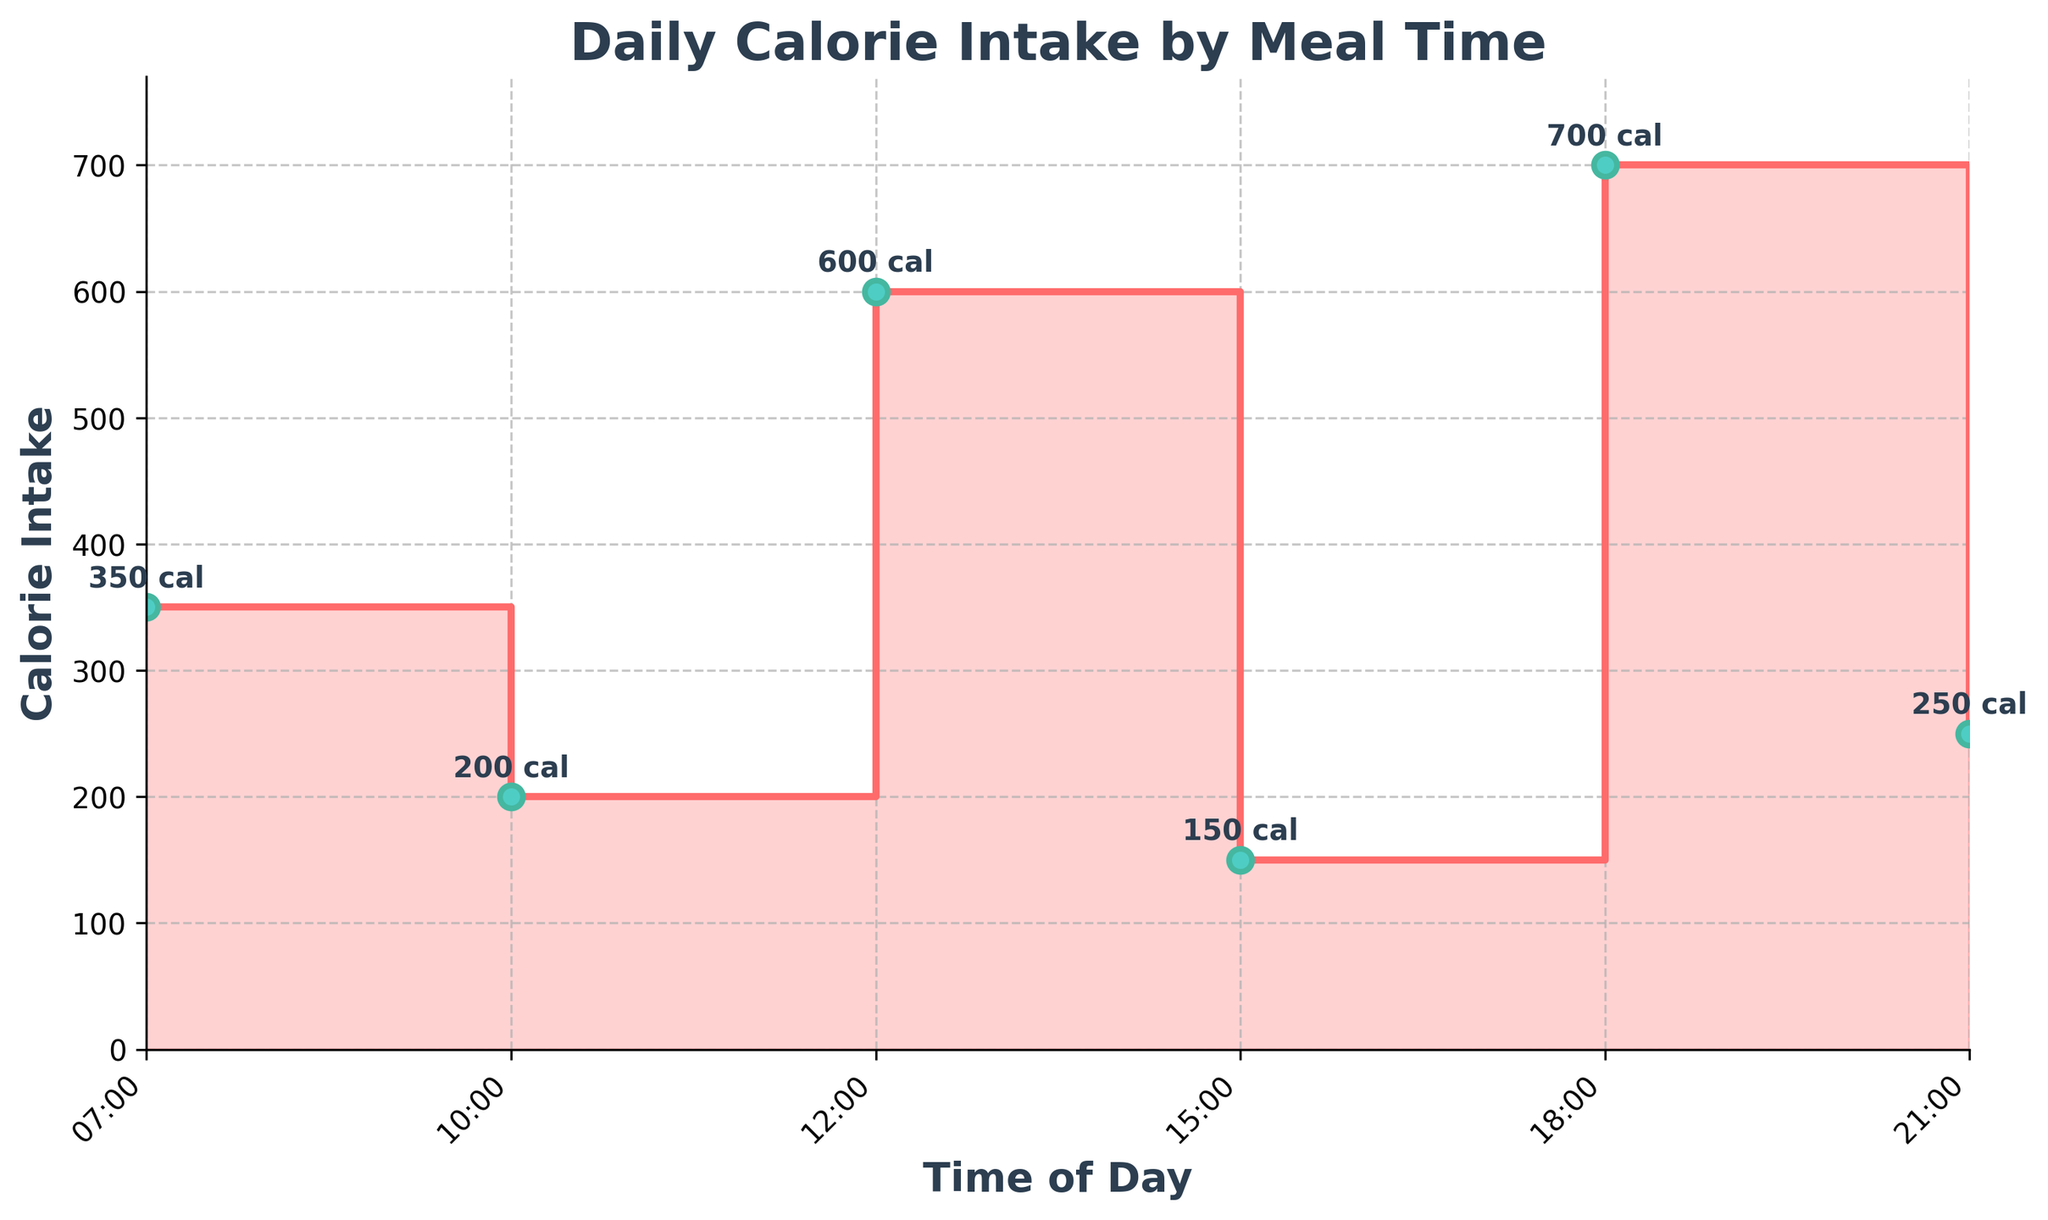What is the title of the figure? The title appears at the top of the figure and provides a summary of what the plot represents. Here, it states "Daily Calorie Intake by Meal Time".
Answer: Daily Calorie Intake by Meal Time How many distinct times of day are represented in the figure? The figure shows six distinct data points along the horizontal axis representing different times of the day.
Answer: Six At what time of the day is the highest calorie intake? By observing the vertical axis, the highest point appears at 18:00 with 700 calories.
Answer: 18:00 What is the calorie intake at 15:00? We can read the specific point on the plot marked at 15:00, where the graph indicates 150 calories.
Answer: 150 Which time interval shows the largest increase in calorie intake? To find this, we look for the interval between two points where the jump in the vertical height is the largest. The interval from 15:00 to 18:00 shows the largest increase, from 150 to 700 calories.
Answer: 15:00 to 18:00 What is the total calorie intake for the entire day? Summing the individual calorie intakes for all times: 350 + 200 + 600 + 150 + 700 + 250 = 2250.
Answer: 2250 What is the difference in calorie intake between 12:00 and 21:00? Subtract the calorie intake at 21:00 from that at 12:00: 600 - 250 = 350.
Answer: 350 What is the average calorie intake across all meal times displayed in the figure? To find the average, sum all the calories and divide by the number of time points (6): (350 + 200 + 600 + 150 + 700 + 250) / 6 = 375.
Answer: 375 Is the calorie intake higher at 07:00 or 21:00? By comparing the calorie intake values directly, 350 at 07:00 and 250 at 21:00.
Answer: 07:00 What color is used to mark the calorie intake points on the plot? Observing the markers on the graph, they are colored in a teal shade.
Answer: Teal 